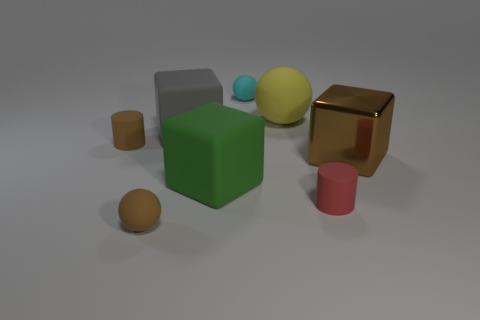What number of cylinders are big gray objects or cyan objects? In the image, there are no cylinders that are either big gray or cyan. All objects appear to be solid, and none of them resemble a cylinder. 